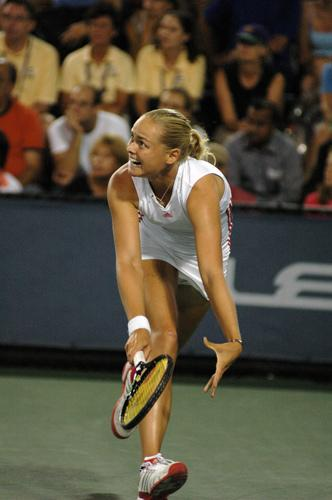What move is this female player making? backhand 